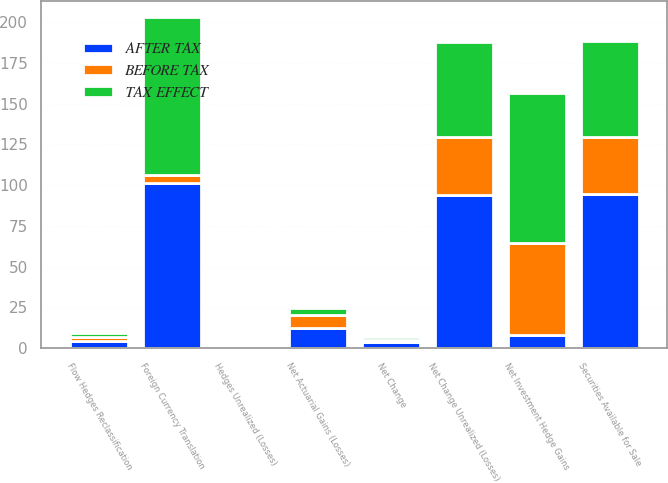Convert chart to OTSL. <chart><loc_0><loc_0><loc_500><loc_500><stacked_bar_chart><ecel><fcel>Securities Available for Sale<fcel>Net Change Unrealized (Losses)<fcel>Hedges Unrealized (Losses)<fcel>Flow Hedges Reclassification<fcel>Net Change<fcel>Foreign Currency Translation<fcel>Net Investment Hedge Gains<fcel>Net Actuarial Gains (Losses)<nl><fcel>AFTER TAX<fcel>94.3<fcel>94<fcel>1.2<fcel>4.7<fcel>3.5<fcel>101.5<fcel>8.2<fcel>12.2<nl><fcel>BEFORE TAX<fcel>35.5<fcel>35.4<fcel>0.2<fcel>2<fcel>1.8<fcel>4.9<fcel>56.3<fcel>8.2<nl><fcel>TAX EFFECT<fcel>58.8<fcel>58.6<fcel>1<fcel>2.7<fcel>1.7<fcel>96.6<fcel>92.3<fcel>4<nl></chart> 